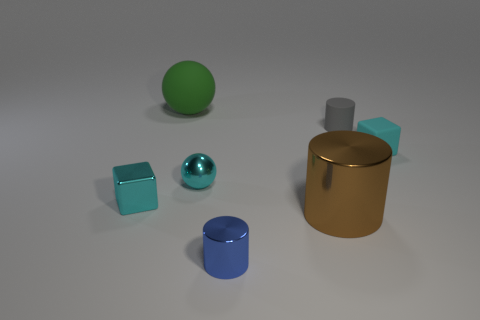Add 2 small purple cylinders. How many objects exist? 9 Subtract all blocks. How many objects are left? 5 Subtract all blue shiny blocks. Subtract all rubber things. How many objects are left? 4 Add 5 tiny blue shiny things. How many tiny blue shiny things are left? 6 Add 5 cyan shiny blocks. How many cyan shiny blocks exist? 6 Subtract 0 yellow balls. How many objects are left? 7 